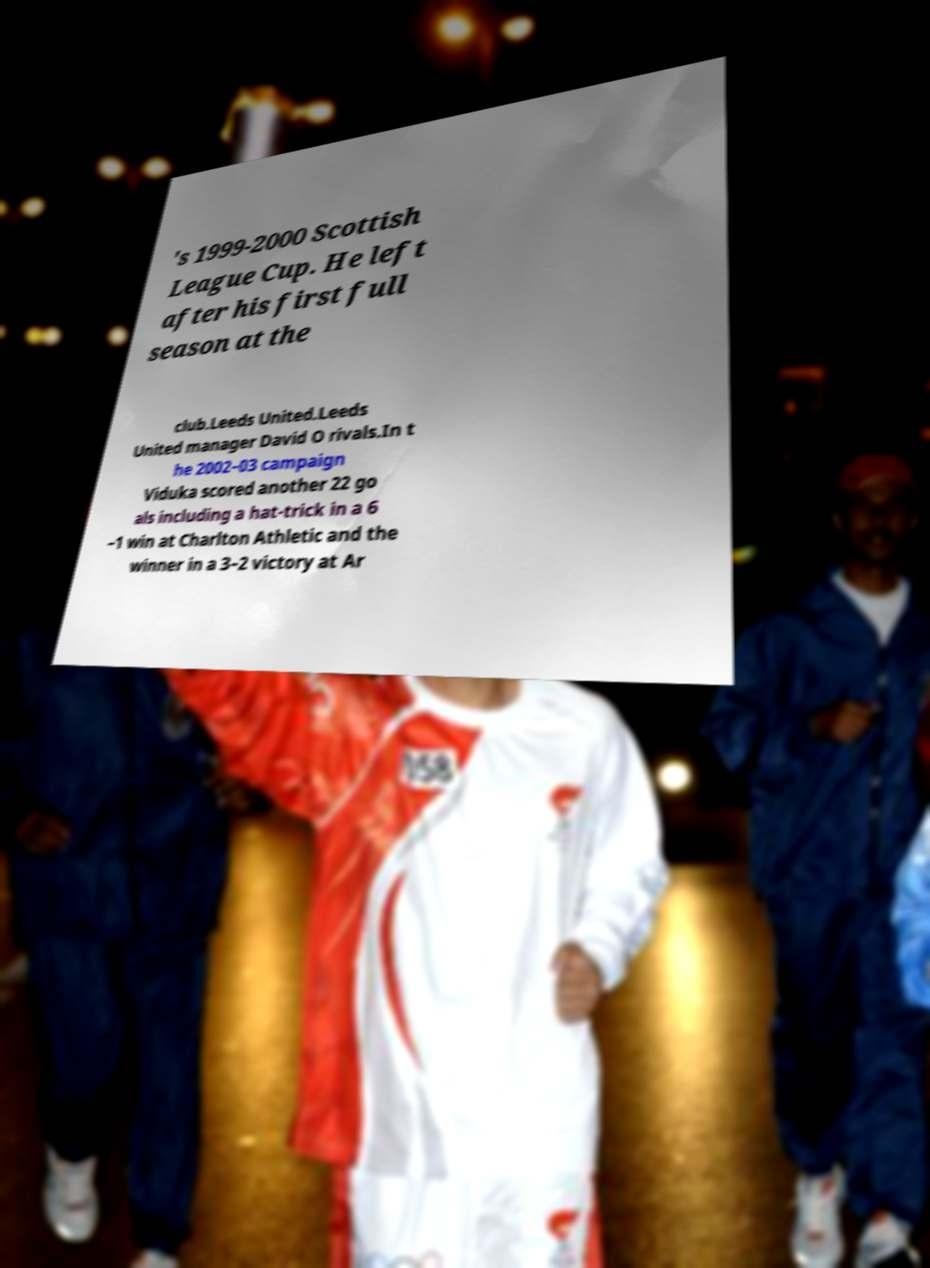What messages or text are displayed in this image? I need them in a readable, typed format. 's 1999-2000 Scottish League Cup. He left after his first full season at the club.Leeds United.Leeds United manager David O rivals.In t he 2002–03 campaign Viduka scored another 22 go als including a hat-trick in a 6 –1 win at Charlton Athletic and the winner in a 3–2 victory at Ar 